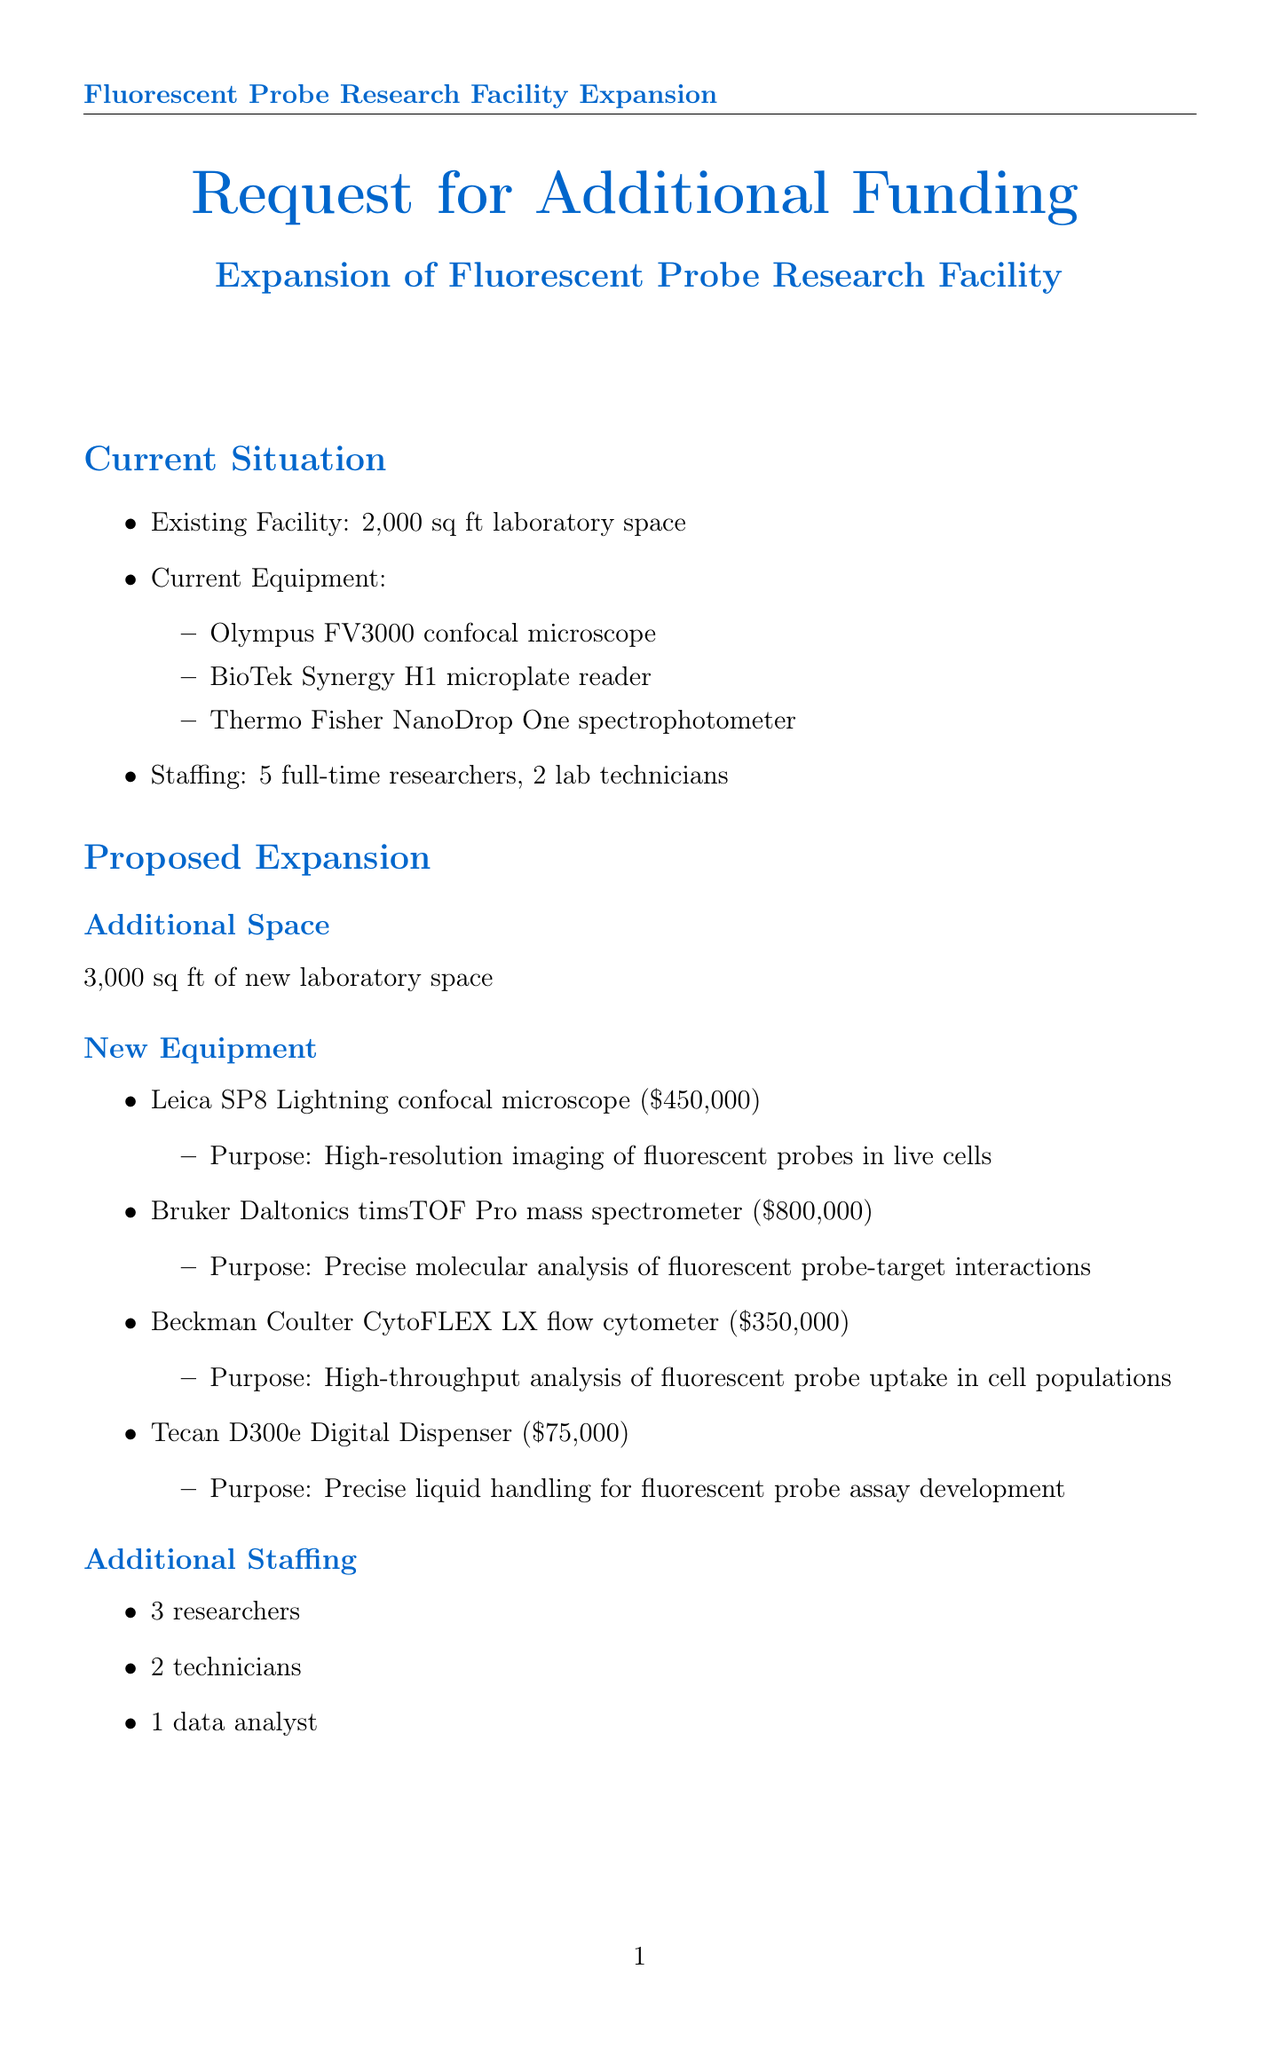What is the existing facility size? The existing facility size is mentioned in the document as 2,000 square feet.
Answer: 2,000 sq ft What new equipment is proposed for acquisition? The document lists several new equipment items, including the Leica SP8 Lightning confocal microscope.
Answer: Leica SP8 Lightning confocal microscope How much is the budget for facility expansion? The facility expansion costs are detailed in the budget summary of the document as $750,000.
Answer: $750,000 What is the total requested funding amount? The total funding requested is the sum of all costs outlined in the budget summary.
Answer: $3,625,000 How many additional researchers are proposed to be hired? The proposal includes hiring additional research staff as specified in the staffing section.
Answer: 3 researchers What is the expected increase in screening capacity? The document states the expected increase in screening capacity for assays is described as a percentage.
Answer: 50% increase What is the timeline for full operational capacity? The timeline indicates the full operational capacity will be achieved within a certain timeframe after funding approval.
Answer: Within 12 months Which article is cited in the supporting data? The document refers to a specific article that highlights the importance of fluorescent probes in drug discovery.
Answer: Nature Chemical Biology article What purpose does the Bruker Daltonics timsTOF Pro mass spectrometer serve? The purpose of this equipment is noted in the document, related to the analysis of fluorescent probes.
Answer: Precise molecular analysis of fluorescent probe-target interactions 